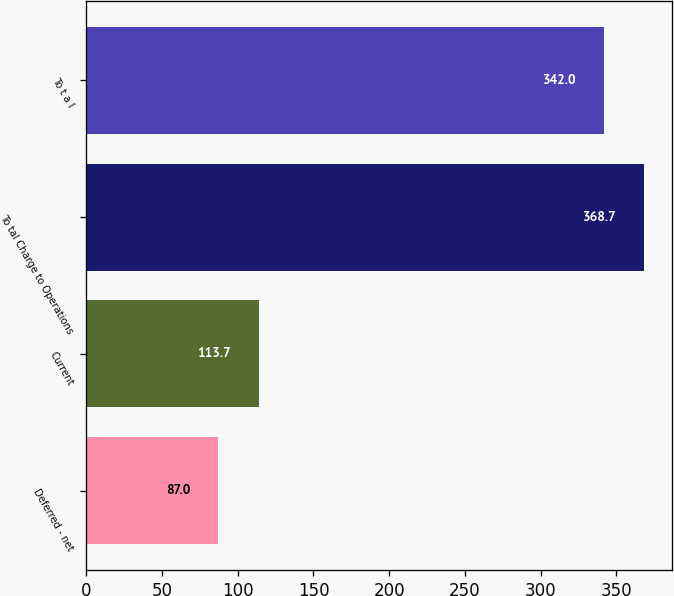Convert chart. <chart><loc_0><loc_0><loc_500><loc_500><bar_chart><fcel>Deferred - net<fcel>Current<fcel>To tal Charge to Operations<fcel>To t a l<nl><fcel>87<fcel>113.7<fcel>368.7<fcel>342<nl></chart> 